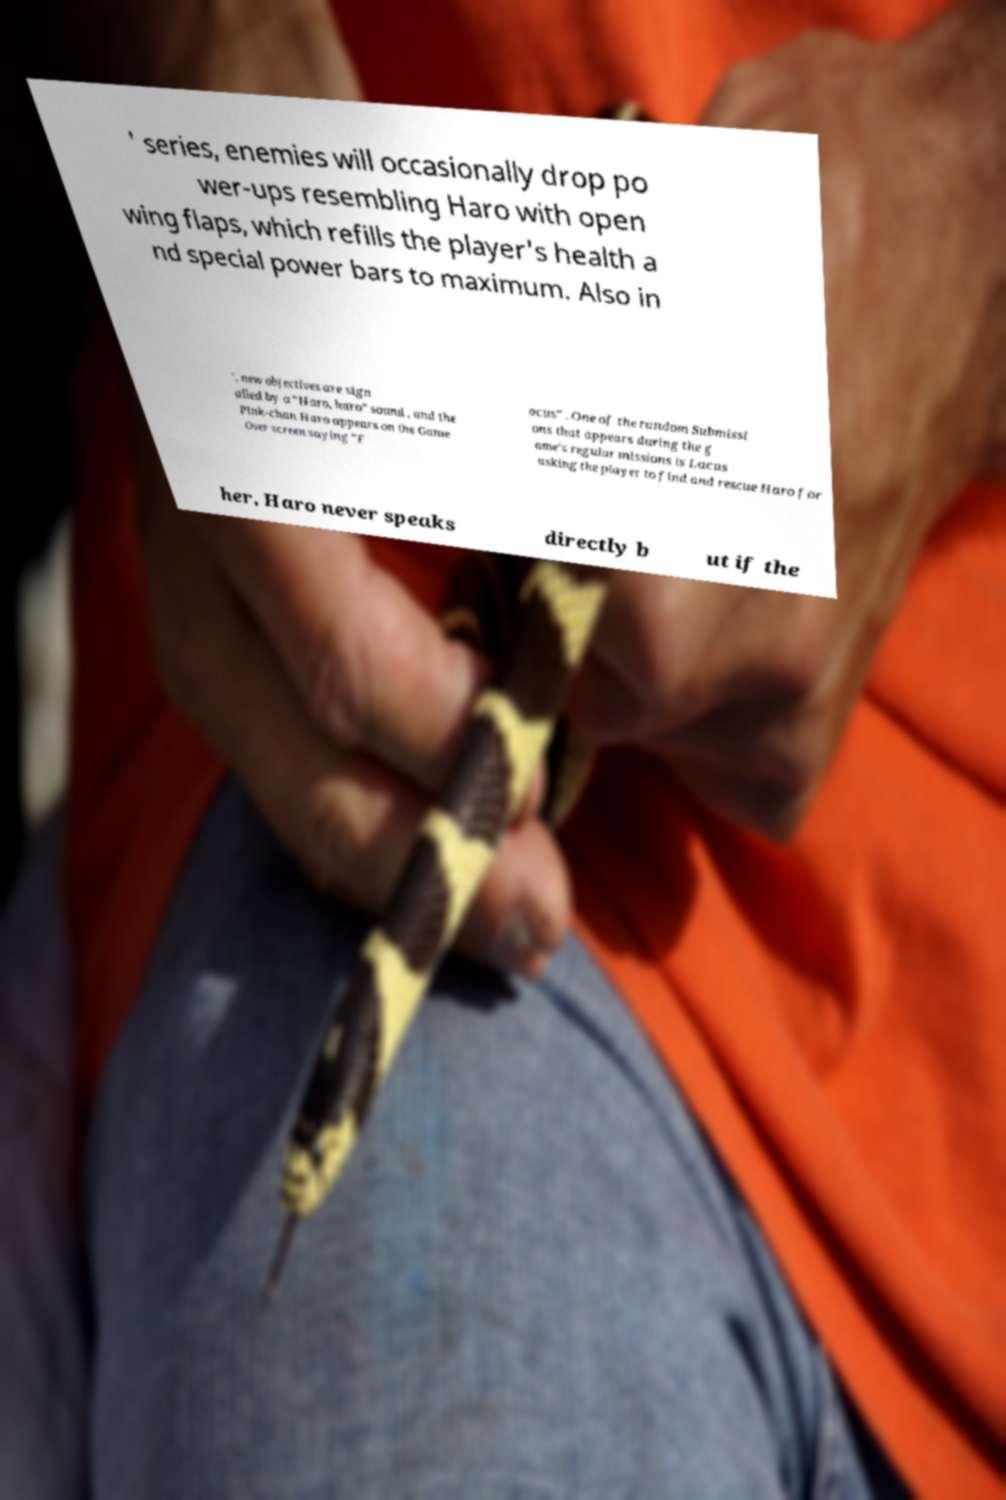Can you accurately transcribe the text from the provided image for me? ' series, enemies will occasionally drop po wer-ups resembling Haro with open wing flaps, which refills the player's health a nd special power bars to maximum. Also in ', new objectives are sign alled by a "Haro, haro" sound , and the Pink-chan Haro appears on the Game Over screen saying "F ocus" . One of the random Submissi ons that appears during the g ame's regular missions is Lacus asking the player to find and rescue Haro for her, Haro never speaks directly b ut if the 